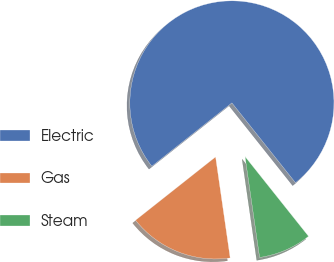<chart> <loc_0><loc_0><loc_500><loc_500><pie_chart><fcel>Electric<fcel>Gas<fcel>Steam<nl><fcel>74.95%<fcel>16.63%<fcel>8.42%<nl></chart> 